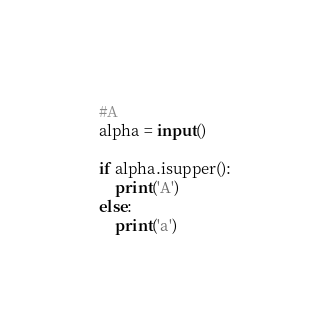<code> <loc_0><loc_0><loc_500><loc_500><_Python_>#A
alpha = input()

if alpha.isupper():
    print('A')
else:
    print('a')
</code> 